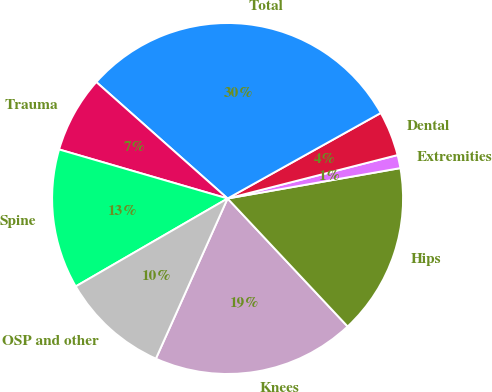Convert chart to OTSL. <chart><loc_0><loc_0><loc_500><loc_500><pie_chart><fcel>Knees<fcel>Hips<fcel>Extremities<fcel>Dental<fcel>Total<fcel>Trauma<fcel>Spine<fcel>OSP and other<nl><fcel>18.69%<fcel>15.78%<fcel>1.21%<fcel>4.12%<fcel>30.35%<fcel>7.04%<fcel>12.86%<fcel>9.95%<nl></chart> 